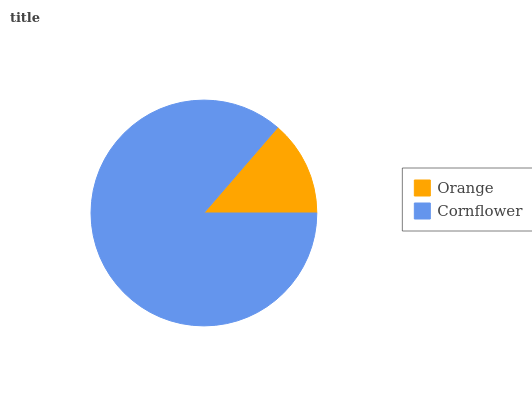Is Orange the minimum?
Answer yes or no. Yes. Is Cornflower the maximum?
Answer yes or no. Yes. Is Cornflower the minimum?
Answer yes or no. No. Is Cornflower greater than Orange?
Answer yes or no. Yes. Is Orange less than Cornflower?
Answer yes or no. Yes. Is Orange greater than Cornflower?
Answer yes or no. No. Is Cornflower less than Orange?
Answer yes or no. No. Is Cornflower the high median?
Answer yes or no. Yes. Is Orange the low median?
Answer yes or no. Yes. Is Orange the high median?
Answer yes or no. No. Is Cornflower the low median?
Answer yes or no. No. 